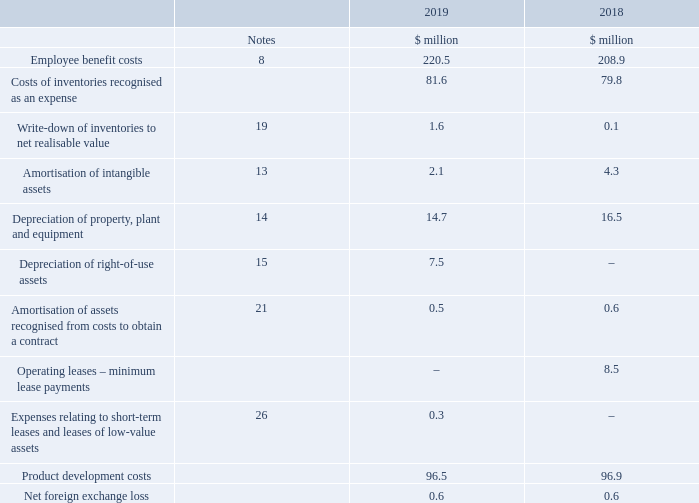4. Profit before tax
The following items have been charged in arriving at profit before tax:
What have the items in the table been charged in arriving at? Profit before tax. What was the amount of employee benefit costs in 2019?
Answer scale should be: million. 220.5. For which years were the items that have been charged in arriving at profit before tax recorded in? 2019, 2018. In which year was the amount of product development costs larger? 96.9>96.5
Answer: 2018. What was the change in employee benefit costs?
Answer scale should be: million. 220.5-208.9
Answer: 11.6. What was the percentage change in employee benefit costs?
Answer scale should be: percent. (220.5-208.9)/208.9
Answer: 5.55. 